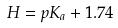<formula> <loc_0><loc_0><loc_500><loc_500>H = p K _ { a } + 1 . 7 4</formula> 